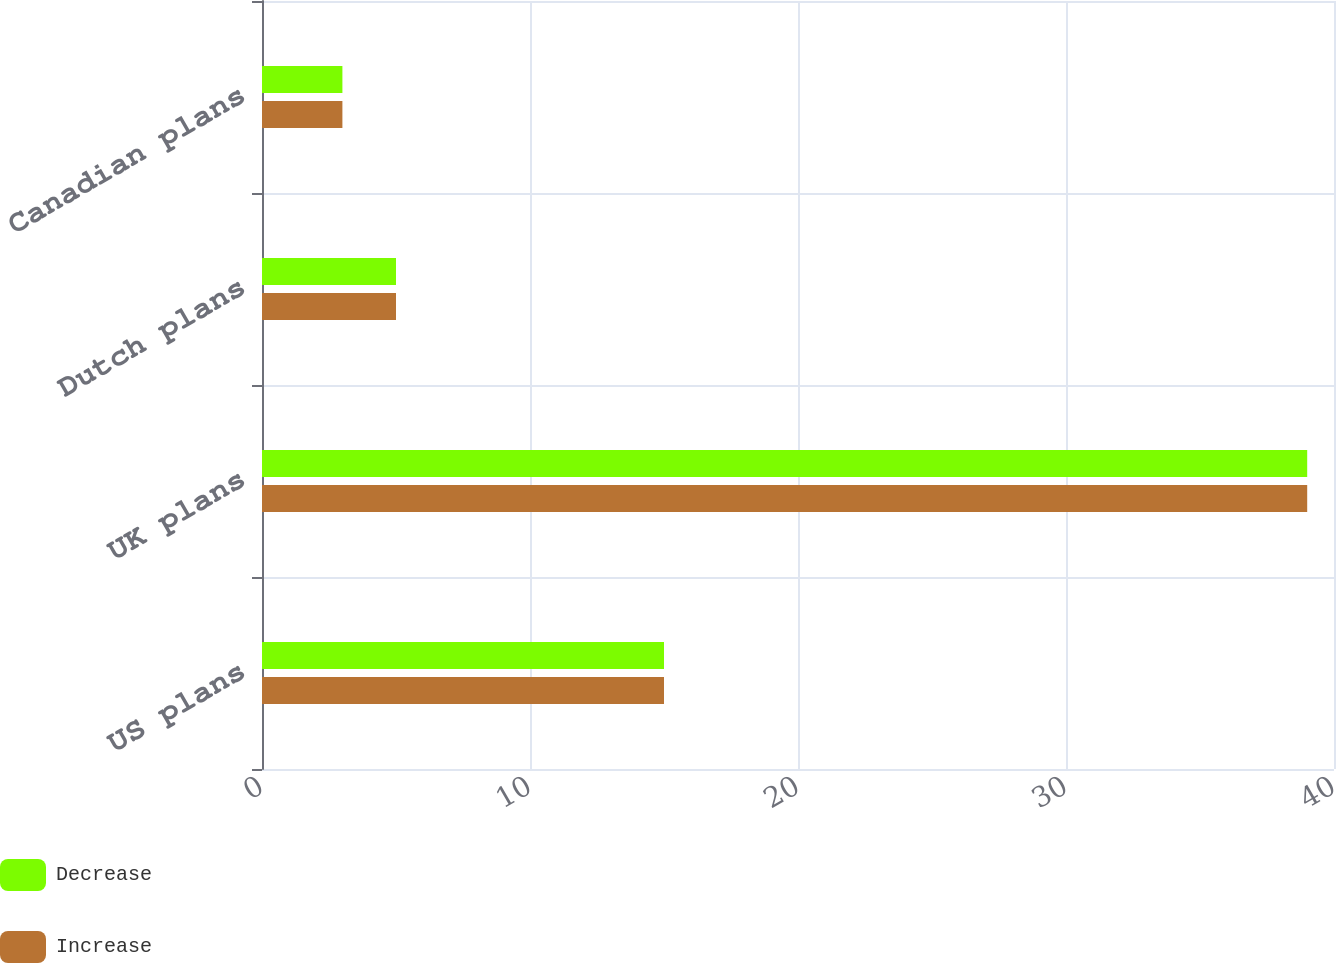Convert chart. <chart><loc_0><loc_0><loc_500><loc_500><stacked_bar_chart><ecel><fcel>US plans<fcel>UK plans<fcel>Dutch plans<fcel>Canadian plans<nl><fcel>Decrease<fcel>15<fcel>39<fcel>5<fcel>3<nl><fcel>Increase<fcel>15<fcel>39<fcel>5<fcel>3<nl></chart> 